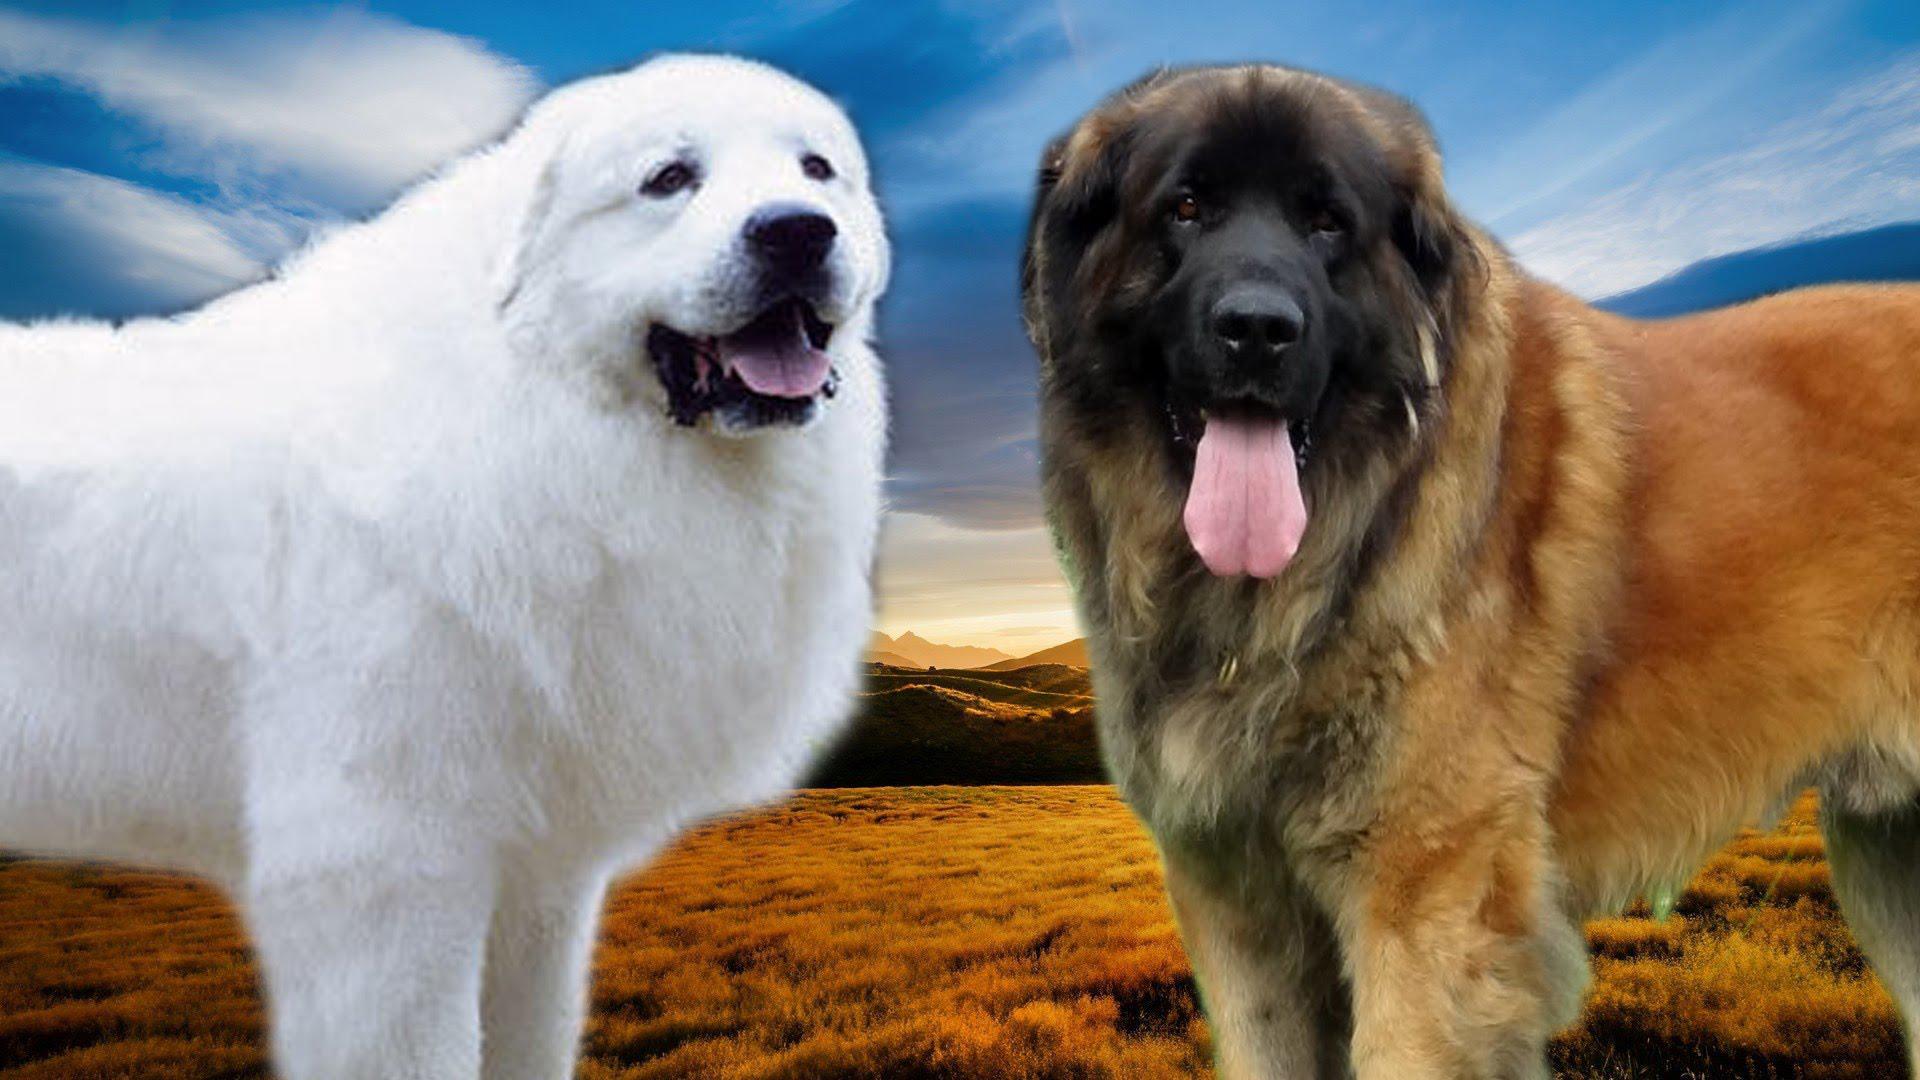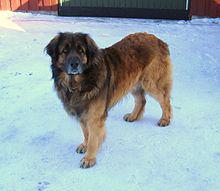The first image is the image on the left, the second image is the image on the right. Examine the images to the left and right. Is the description "In one of the images, one dog is predominantly white, while the other is predominantly brown." accurate? Answer yes or no. Yes. The first image is the image on the left, the second image is the image on the right. Considering the images on both sides, is "The right image has exactly two dogs." valid? Answer yes or no. No. 